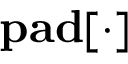Convert formula to latex. <formula><loc_0><loc_0><loc_500><loc_500>p a d [ \cdot ]</formula> 